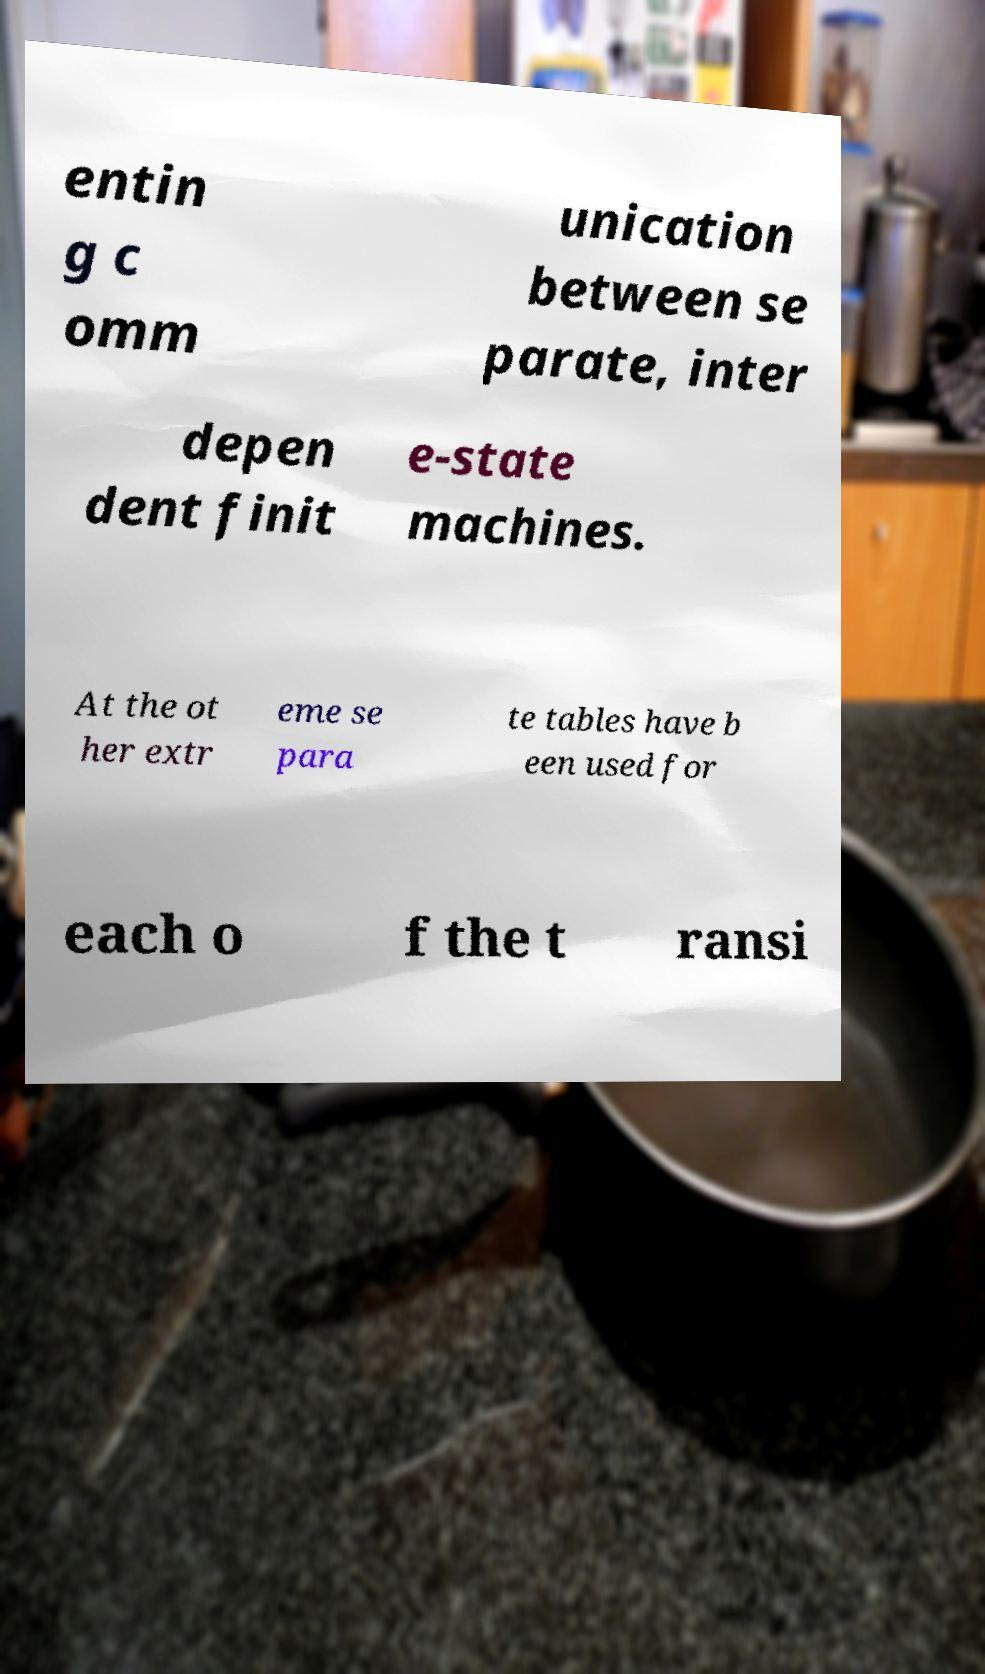Could you assist in decoding the text presented in this image and type it out clearly? entin g c omm unication between se parate, inter depen dent finit e-state machines. At the ot her extr eme se para te tables have b een used for each o f the t ransi 